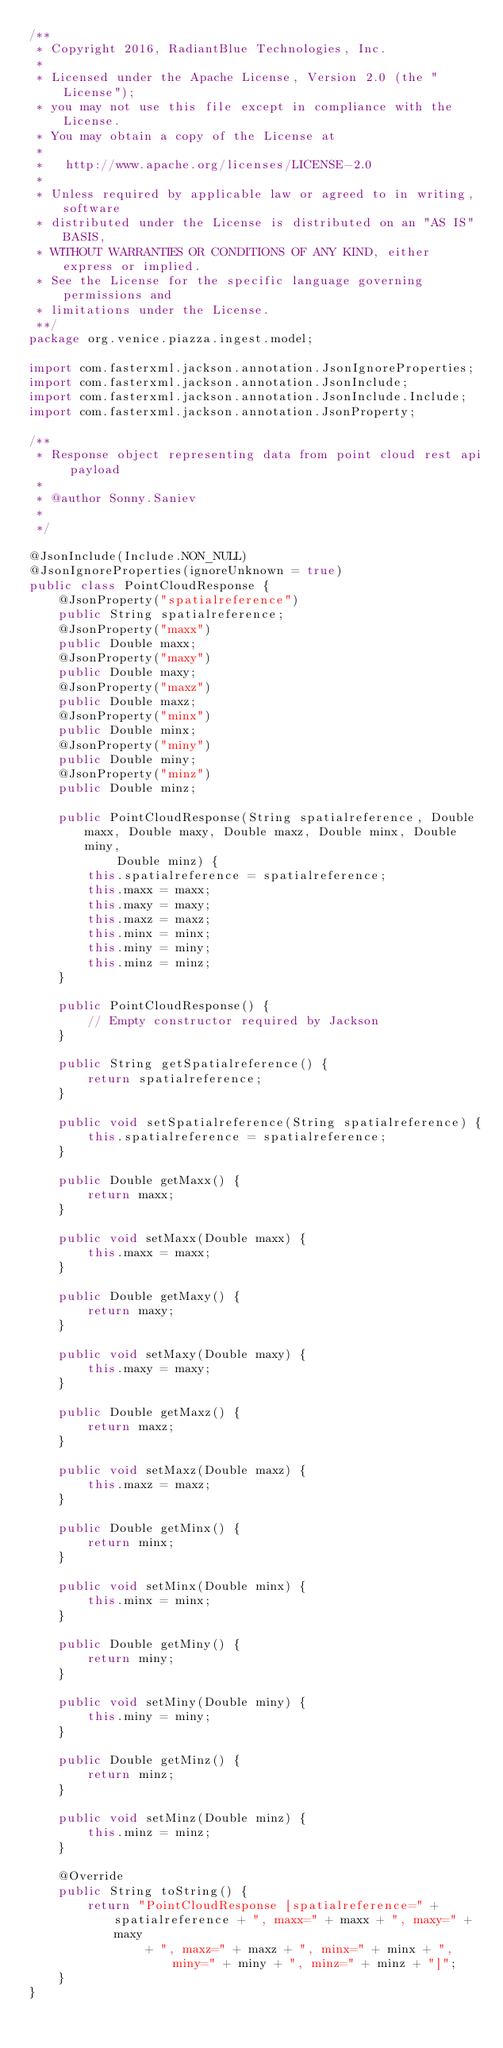<code> <loc_0><loc_0><loc_500><loc_500><_Java_>/**
 * Copyright 2016, RadiantBlue Technologies, Inc.
 * 
 * Licensed under the Apache License, Version 2.0 (the "License");
 * you may not use this file except in compliance with the License.
 * You may obtain a copy of the License at
 * 
 *   http://www.apache.org/licenses/LICENSE-2.0
 * 
 * Unless required by applicable law or agreed to in writing, software
 * distributed under the License is distributed on an "AS IS" BASIS,
 * WITHOUT WARRANTIES OR CONDITIONS OF ANY KIND, either express or implied.
 * See the License for the specific language governing permissions and
 * limitations under the License.
 **/
package org.venice.piazza.ingest.model;

import com.fasterxml.jackson.annotation.JsonIgnoreProperties;
import com.fasterxml.jackson.annotation.JsonInclude;
import com.fasterxml.jackson.annotation.JsonInclude.Include;
import com.fasterxml.jackson.annotation.JsonProperty;

/**
 * Response object representing data from point cloud rest api payload
 * 
 * @author Sonny.Saniev
 * 
 */

@JsonInclude(Include.NON_NULL)
@JsonIgnoreProperties(ignoreUnknown = true)
public class PointCloudResponse {
	@JsonProperty("spatialreference")
	public String spatialreference;
	@JsonProperty("maxx")
	public Double maxx;
	@JsonProperty("maxy")
	public Double maxy;
	@JsonProperty("maxz")
	public Double maxz;
	@JsonProperty("minx")
	public Double minx;
	@JsonProperty("miny")
	public Double miny;
	@JsonProperty("minz")
	public Double minz;

	public PointCloudResponse(String spatialreference, Double maxx, Double maxy, Double maxz, Double minx, Double miny,
			Double minz) {
		this.spatialreference = spatialreference;
		this.maxx = maxx;
		this.maxy = maxy;
		this.maxz = maxz;
		this.minx = minx;
		this.miny = miny;
		this.minz = minz;
	}

	public PointCloudResponse() {
		// Empty constructor required by Jackson
	}

	public String getSpatialreference() {
		return spatialreference;
	}

	public void setSpatialreference(String spatialreference) {
		this.spatialreference = spatialreference;
	}

	public Double getMaxx() {
		return maxx;
	}

	public void setMaxx(Double maxx) {
		this.maxx = maxx;
	}

	public Double getMaxy() {
		return maxy;
	}

	public void setMaxy(Double maxy) {
		this.maxy = maxy;
	}

	public Double getMaxz() {
		return maxz;
	}

	public void setMaxz(Double maxz) {
		this.maxz = maxz;
	}

	public Double getMinx() {
		return minx;
	}

	public void setMinx(Double minx) {
		this.minx = minx;
	}

	public Double getMiny() {
		return miny;
	}

	public void setMiny(Double miny) {
		this.miny = miny;
	}

	public Double getMinz() {
		return minz;
	}

	public void setMinz(Double minz) {
		this.minz = minz;
	}

	@Override
	public String toString() {
		return "PointCloudResponse [spatialreference=" + spatialreference + ", maxx=" + maxx + ", maxy=" + maxy
				+ ", maxz=" + maxz + ", minx=" + minx + ", miny=" + miny + ", minz=" + minz + "]";
	}
}
</code> 